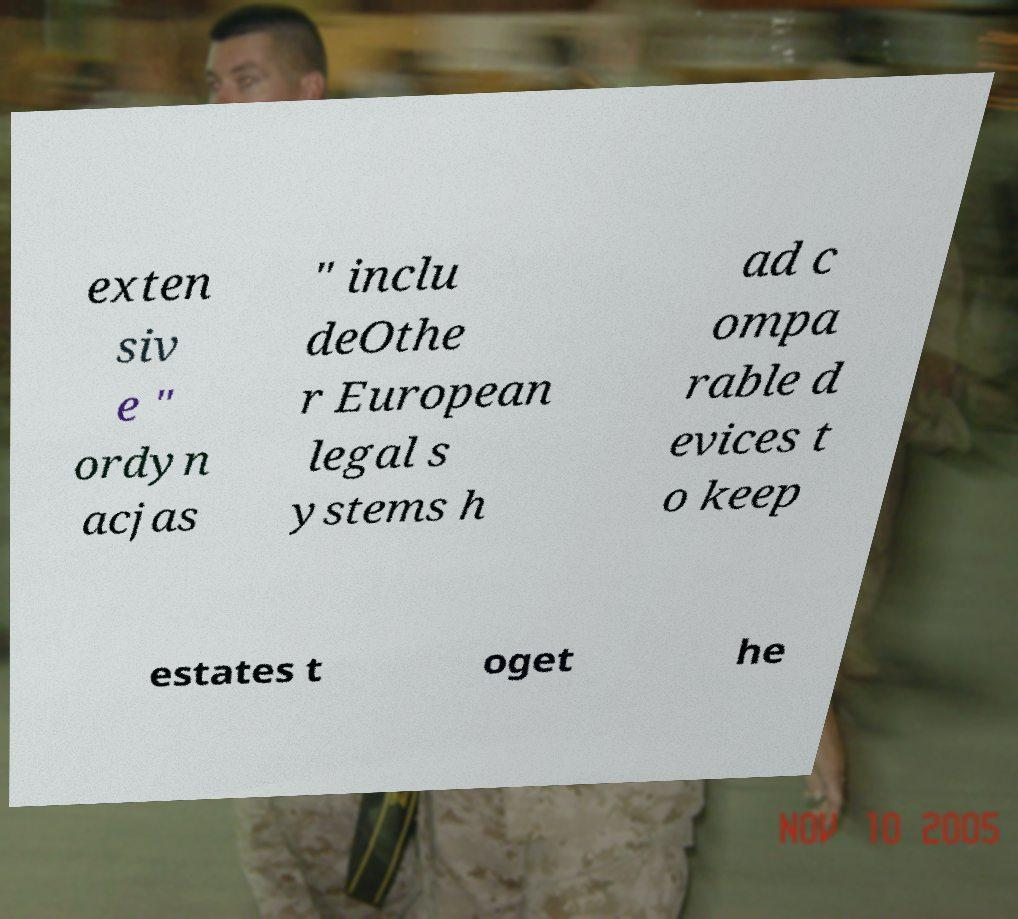For documentation purposes, I need the text within this image transcribed. Could you provide that? exten siv e " ordyn acjas " inclu deOthe r European legal s ystems h ad c ompa rable d evices t o keep estates t oget he 